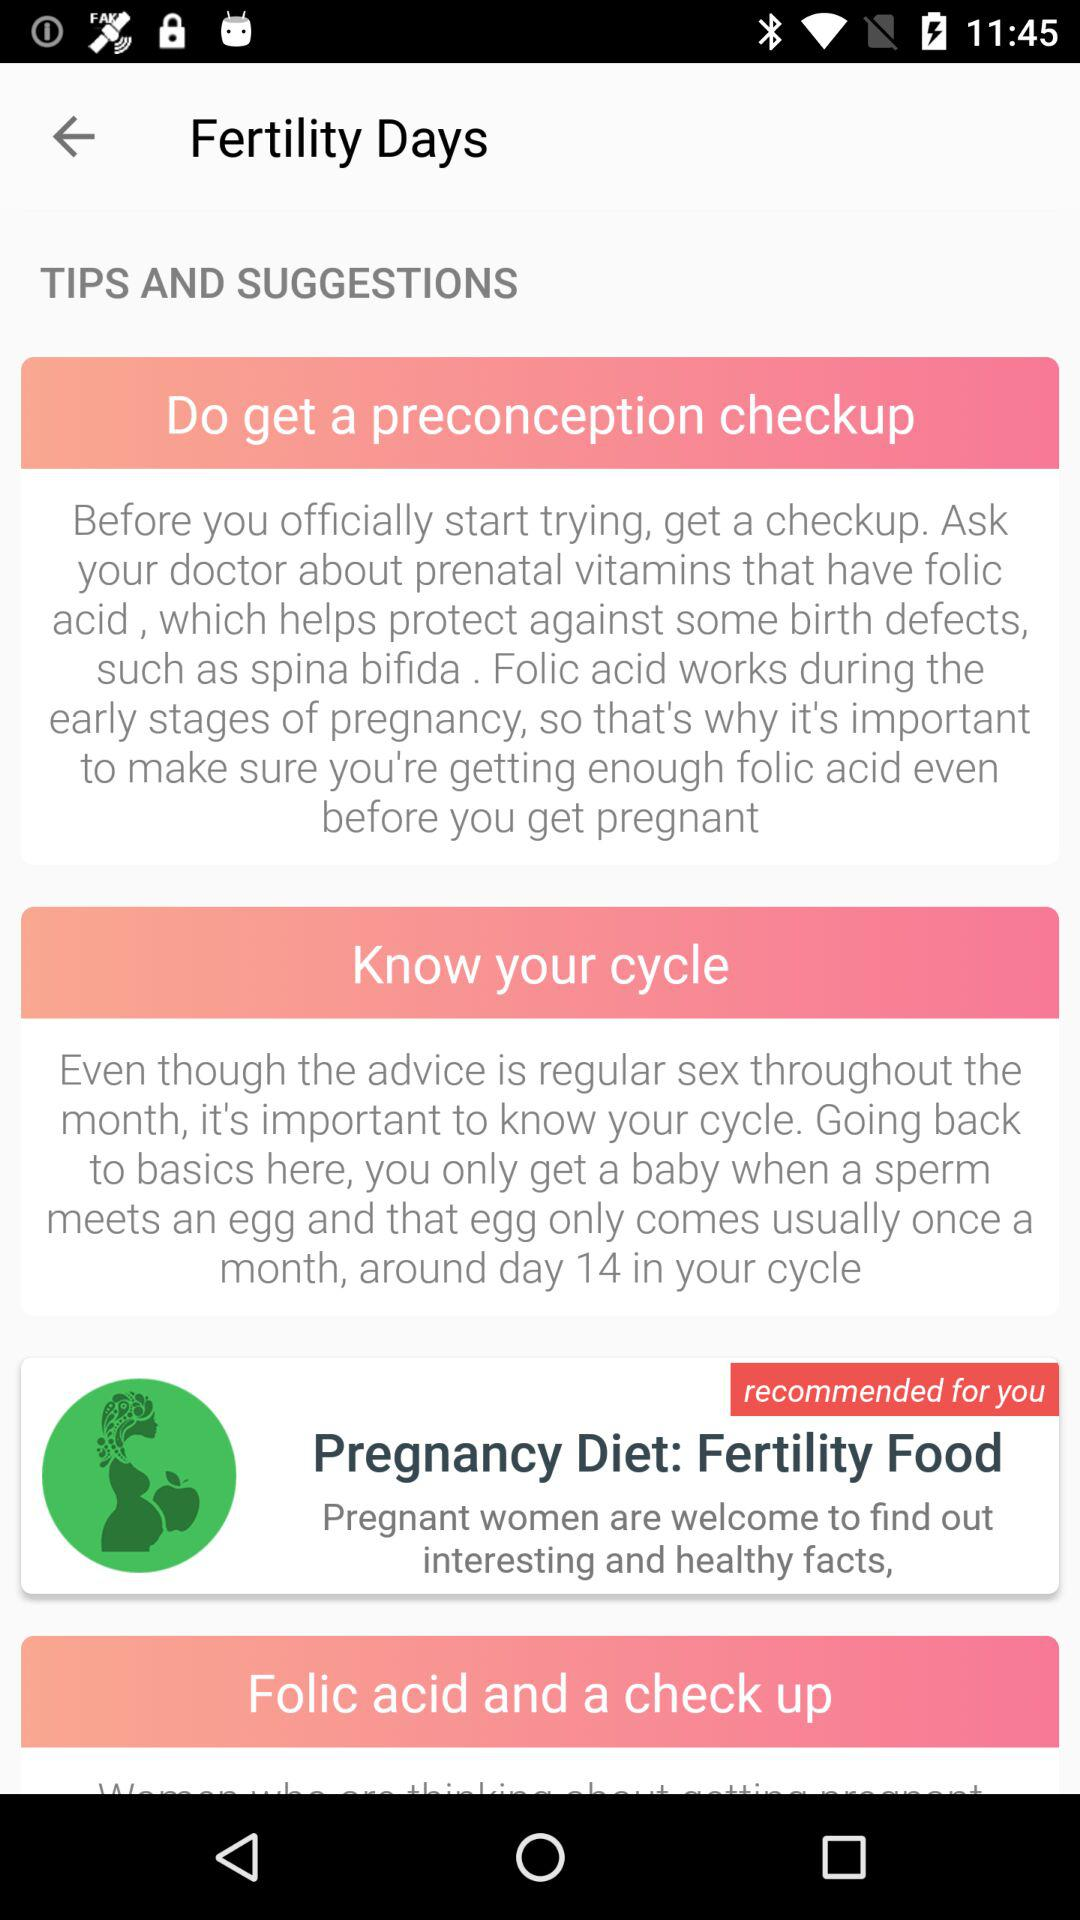How many tips are there in total?
Answer the question using a single word or phrase. 3 